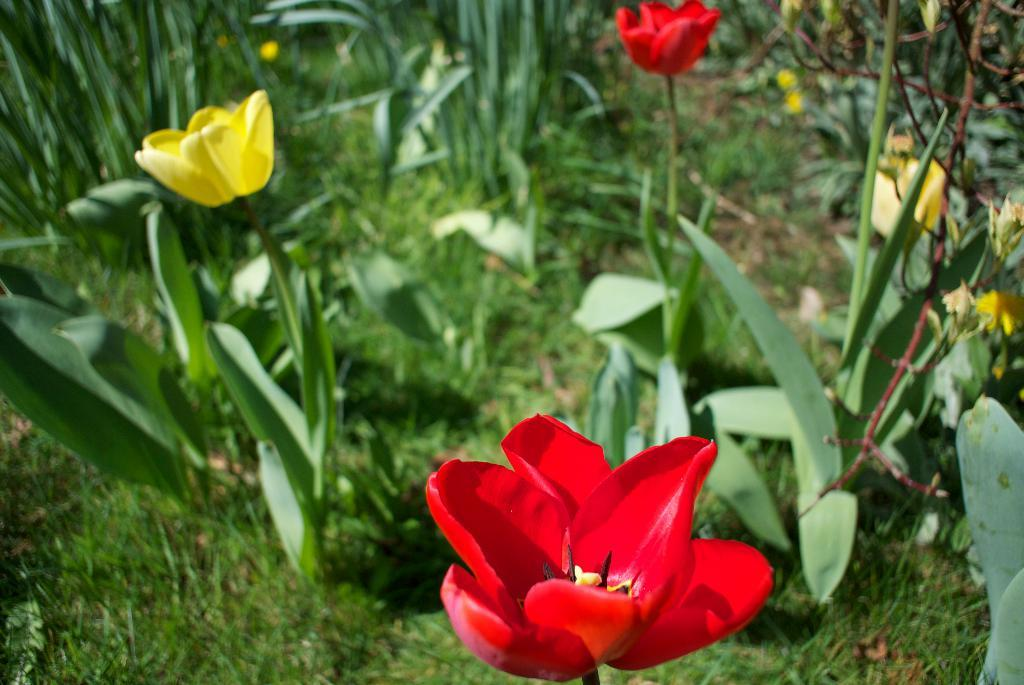What type of living organisms can be seen in the image? Plants can be seen in the image. What color are the flowers on the plants in the image? The plants have red flowers and yellow flowers. What song is being played in the background of the image? There is no information about a song being played in the image, as the focus is on the plants and their flowers. 